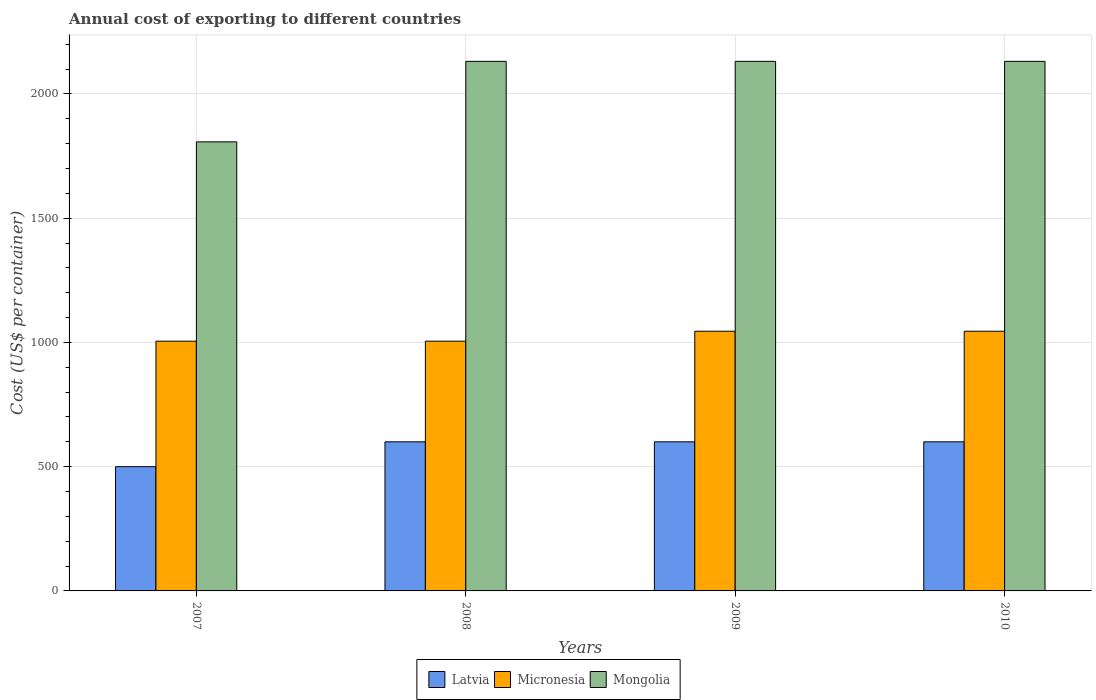How many different coloured bars are there?
Provide a succinct answer. 3. How many groups of bars are there?
Give a very brief answer. 4. Are the number of bars per tick equal to the number of legend labels?
Your answer should be compact. Yes. Are the number of bars on each tick of the X-axis equal?
Ensure brevity in your answer.  Yes. What is the total annual cost of exporting in Micronesia in 2007?
Give a very brief answer. 1005. Across all years, what is the maximum total annual cost of exporting in Latvia?
Your response must be concise. 600. Across all years, what is the minimum total annual cost of exporting in Micronesia?
Offer a terse response. 1005. In which year was the total annual cost of exporting in Mongolia maximum?
Your response must be concise. 2008. In which year was the total annual cost of exporting in Micronesia minimum?
Keep it short and to the point. 2007. What is the total total annual cost of exporting in Micronesia in the graph?
Keep it short and to the point. 4100. What is the difference between the total annual cost of exporting in Micronesia in 2008 and the total annual cost of exporting in Mongolia in 2010?
Give a very brief answer. -1126. What is the average total annual cost of exporting in Micronesia per year?
Your answer should be very brief. 1025. In the year 2008, what is the difference between the total annual cost of exporting in Micronesia and total annual cost of exporting in Latvia?
Your answer should be compact. 405. What is the ratio of the total annual cost of exporting in Micronesia in 2007 to that in 2009?
Your response must be concise. 0.96. Is the total annual cost of exporting in Latvia in 2007 less than that in 2009?
Keep it short and to the point. Yes. Is the difference between the total annual cost of exporting in Micronesia in 2007 and 2009 greater than the difference between the total annual cost of exporting in Latvia in 2007 and 2009?
Provide a short and direct response. Yes. What is the difference between the highest and the second highest total annual cost of exporting in Mongolia?
Offer a terse response. 0. What is the difference between the highest and the lowest total annual cost of exporting in Latvia?
Offer a terse response. 100. In how many years, is the total annual cost of exporting in Mongolia greater than the average total annual cost of exporting in Mongolia taken over all years?
Keep it short and to the point. 3. What does the 1st bar from the left in 2007 represents?
Offer a terse response. Latvia. What does the 3rd bar from the right in 2010 represents?
Provide a short and direct response. Latvia. Is it the case that in every year, the sum of the total annual cost of exporting in Mongolia and total annual cost of exporting in Micronesia is greater than the total annual cost of exporting in Latvia?
Ensure brevity in your answer.  Yes. How many bars are there?
Provide a short and direct response. 12. Does the graph contain grids?
Your answer should be compact. Yes. How are the legend labels stacked?
Ensure brevity in your answer.  Horizontal. What is the title of the graph?
Your response must be concise. Annual cost of exporting to different countries. Does "Congo (Republic)" appear as one of the legend labels in the graph?
Provide a succinct answer. No. What is the label or title of the Y-axis?
Provide a succinct answer. Cost (US$ per container). What is the Cost (US$ per container) in Micronesia in 2007?
Offer a terse response. 1005. What is the Cost (US$ per container) in Mongolia in 2007?
Make the answer very short. 1807. What is the Cost (US$ per container) of Latvia in 2008?
Ensure brevity in your answer.  600. What is the Cost (US$ per container) in Micronesia in 2008?
Ensure brevity in your answer.  1005. What is the Cost (US$ per container) of Mongolia in 2008?
Keep it short and to the point. 2131. What is the Cost (US$ per container) of Latvia in 2009?
Your answer should be compact. 600. What is the Cost (US$ per container) of Micronesia in 2009?
Offer a terse response. 1045. What is the Cost (US$ per container) in Mongolia in 2009?
Your answer should be compact. 2131. What is the Cost (US$ per container) in Latvia in 2010?
Provide a succinct answer. 600. What is the Cost (US$ per container) of Micronesia in 2010?
Your answer should be compact. 1045. What is the Cost (US$ per container) in Mongolia in 2010?
Keep it short and to the point. 2131. Across all years, what is the maximum Cost (US$ per container) of Latvia?
Provide a succinct answer. 600. Across all years, what is the maximum Cost (US$ per container) of Micronesia?
Offer a very short reply. 1045. Across all years, what is the maximum Cost (US$ per container) of Mongolia?
Provide a succinct answer. 2131. Across all years, what is the minimum Cost (US$ per container) in Micronesia?
Your answer should be very brief. 1005. Across all years, what is the minimum Cost (US$ per container) of Mongolia?
Provide a short and direct response. 1807. What is the total Cost (US$ per container) of Latvia in the graph?
Keep it short and to the point. 2300. What is the total Cost (US$ per container) in Micronesia in the graph?
Your answer should be very brief. 4100. What is the total Cost (US$ per container) of Mongolia in the graph?
Provide a short and direct response. 8200. What is the difference between the Cost (US$ per container) in Latvia in 2007 and that in 2008?
Your response must be concise. -100. What is the difference between the Cost (US$ per container) of Mongolia in 2007 and that in 2008?
Your response must be concise. -324. What is the difference between the Cost (US$ per container) in Latvia in 2007 and that in 2009?
Ensure brevity in your answer.  -100. What is the difference between the Cost (US$ per container) in Mongolia in 2007 and that in 2009?
Your response must be concise. -324. What is the difference between the Cost (US$ per container) in Latvia in 2007 and that in 2010?
Provide a short and direct response. -100. What is the difference between the Cost (US$ per container) in Mongolia in 2007 and that in 2010?
Offer a very short reply. -324. What is the difference between the Cost (US$ per container) of Micronesia in 2008 and that in 2009?
Your answer should be compact. -40. What is the difference between the Cost (US$ per container) in Mongolia in 2008 and that in 2009?
Ensure brevity in your answer.  0. What is the difference between the Cost (US$ per container) of Latvia in 2008 and that in 2010?
Your answer should be compact. 0. What is the difference between the Cost (US$ per container) of Micronesia in 2008 and that in 2010?
Give a very brief answer. -40. What is the difference between the Cost (US$ per container) of Mongolia in 2008 and that in 2010?
Offer a terse response. 0. What is the difference between the Cost (US$ per container) in Latvia in 2009 and that in 2010?
Offer a very short reply. 0. What is the difference between the Cost (US$ per container) of Micronesia in 2009 and that in 2010?
Offer a terse response. 0. What is the difference between the Cost (US$ per container) in Mongolia in 2009 and that in 2010?
Your response must be concise. 0. What is the difference between the Cost (US$ per container) in Latvia in 2007 and the Cost (US$ per container) in Micronesia in 2008?
Your response must be concise. -505. What is the difference between the Cost (US$ per container) in Latvia in 2007 and the Cost (US$ per container) in Mongolia in 2008?
Provide a succinct answer. -1631. What is the difference between the Cost (US$ per container) in Micronesia in 2007 and the Cost (US$ per container) in Mongolia in 2008?
Provide a short and direct response. -1126. What is the difference between the Cost (US$ per container) of Latvia in 2007 and the Cost (US$ per container) of Micronesia in 2009?
Your answer should be compact. -545. What is the difference between the Cost (US$ per container) of Latvia in 2007 and the Cost (US$ per container) of Mongolia in 2009?
Provide a short and direct response. -1631. What is the difference between the Cost (US$ per container) in Micronesia in 2007 and the Cost (US$ per container) in Mongolia in 2009?
Give a very brief answer. -1126. What is the difference between the Cost (US$ per container) of Latvia in 2007 and the Cost (US$ per container) of Micronesia in 2010?
Your answer should be very brief. -545. What is the difference between the Cost (US$ per container) of Latvia in 2007 and the Cost (US$ per container) of Mongolia in 2010?
Your answer should be compact. -1631. What is the difference between the Cost (US$ per container) in Micronesia in 2007 and the Cost (US$ per container) in Mongolia in 2010?
Keep it short and to the point. -1126. What is the difference between the Cost (US$ per container) in Latvia in 2008 and the Cost (US$ per container) in Micronesia in 2009?
Offer a terse response. -445. What is the difference between the Cost (US$ per container) in Latvia in 2008 and the Cost (US$ per container) in Mongolia in 2009?
Your answer should be very brief. -1531. What is the difference between the Cost (US$ per container) in Micronesia in 2008 and the Cost (US$ per container) in Mongolia in 2009?
Your answer should be compact. -1126. What is the difference between the Cost (US$ per container) of Latvia in 2008 and the Cost (US$ per container) of Micronesia in 2010?
Make the answer very short. -445. What is the difference between the Cost (US$ per container) of Latvia in 2008 and the Cost (US$ per container) of Mongolia in 2010?
Your response must be concise. -1531. What is the difference between the Cost (US$ per container) of Micronesia in 2008 and the Cost (US$ per container) of Mongolia in 2010?
Offer a very short reply. -1126. What is the difference between the Cost (US$ per container) of Latvia in 2009 and the Cost (US$ per container) of Micronesia in 2010?
Offer a very short reply. -445. What is the difference between the Cost (US$ per container) of Latvia in 2009 and the Cost (US$ per container) of Mongolia in 2010?
Your response must be concise. -1531. What is the difference between the Cost (US$ per container) in Micronesia in 2009 and the Cost (US$ per container) in Mongolia in 2010?
Provide a short and direct response. -1086. What is the average Cost (US$ per container) of Latvia per year?
Make the answer very short. 575. What is the average Cost (US$ per container) in Micronesia per year?
Make the answer very short. 1025. What is the average Cost (US$ per container) of Mongolia per year?
Provide a succinct answer. 2050. In the year 2007, what is the difference between the Cost (US$ per container) of Latvia and Cost (US$ per container) of Micronesia?
Ensure brevity in your answer.  -505. In the year 2007, what is the difference between the Cost (US$ per container) of Latvia and Cost (US$ per container) of Mongolia?
Provide a succinct answer. -1307. In the year 2007, what is the difference between the Cost (US$ per container) in Micronesia and Cost (US$ per container) in Mongolia?
Your response must be concise. -802. In the year 2008, what is the difference between the Cost (US$ per container) of Latvia and Cost (US$ per container) of Micronesia?
Your answer should be very brief. -405. In the year 2008, what is the difference between the Cost (US$ per container) in Latvia and Cost (US$ per container) in Mongolia?
Provide a short and direct response. -1531. In the year 2008, what is the difference between the Cost (US$ per container) of Micronesia and Cost (US$ per container) of Mongolia?
Your answer should be compact. -1126. In the year 2009, what is the difference between the Cost (US$ per container) of Latvia and Cost (US$ per container) of Micronesia?
Offer a terse response. -445. In the year 2009, what is the difference between the Cost (US$ per container) of Latvia and Cost (US$ per container) of Mongolia?
Offer a terse response. -1531. In the year 2009, what is the difference between the Cost (US$ per container) in Micronesia and Cost (US$ per container) in Mongolia?
Ensure brevity in your answer.  -1086. In the year 2010, what is the difference between the Cost (US$ per container) of Latvia and Cost (US$ per container) of Micronesia?
Your answer should be very brief. -445. In the year 2010, what is the difference between the Cost (US$ per container) in Latvia and Cost (US$ per container) in Mongolia?
Give a very brief answer. -1531. In the year 2010, what is the difference between the Cost (US$ per container) of Micronesia and Cost (US$ per container) of Mongolia?
Your response must be concise. -1086. What is the ratio of the Cost (US$ per container) in Latvia in 2007 to that in 2008?
Make the answer very short. 0.83. What is the ratio of the Cost (US$ per container) of Micronesia in 2007 to that in 2008?
Give a very brief answer. 1. What is the ratio of the Cost (US$ per container) of Mongolia in 2007 to that in 2008?
Offer a very short reply. 0.85. What is the ratio of the Cost (US$ per container) of Micronesia in 2007 to that in 2009?
Make the answer very short. 0.96. What is the ratio of the Cost (US$ per container) of Mongolia in 2007 to that in 2009?
Offer a very short reply. 0.85. What is the ratio of the Cost (US$ per container) in Micronesia in 2007 to that in 2010?
Provide a short and direct response. 0.96. What is the ratio of the Cost (US$ per container) of Mongolia in 2007 to that in 2010?
Offer a very short reply. 0.85. What is the ratio of the Cost (US$ per container) in Micronesia in 2008 to that in 2009?
Offer a very short reply. 0.96. What is the ratio of the Cost (US$ per container) in Micronesia in 2008 to that in 2010?
Your answer should be compact. 0.96. What is the ratio of the Cost (US$ per container) in Mongolia in 2008 to that in 2010?
Your answer should be very brief. 1. What is the ratio of the Cost (US$ per container) in Micronesia in 2009 to that in 2010?
Give a very brief answer. 1. What is the ratio of the Cost (US$ per container) of Mongolia in 2009 to that in 2010?
Give a very brief answer. 1. What is the difference between the highest and the second highest Cost (US$ per container) of Micronesia?
Provide a short and direct response. 0. What is the difference between the highest and the second highest Cost (US$ per container) in Mongolia?
Make the answer very short. 0. What is the difference between the highest and the lowest Cost (US$ per container) of Mongolia?
Your response must be concise. 324. 